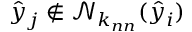<formula> <loc_0><loc_0><loc_500><loc_500>\hat { y } _ { j } \notin \mathcal { N } _ { k _ { n n } } ( \hat { y } _ { i } )</formula> 